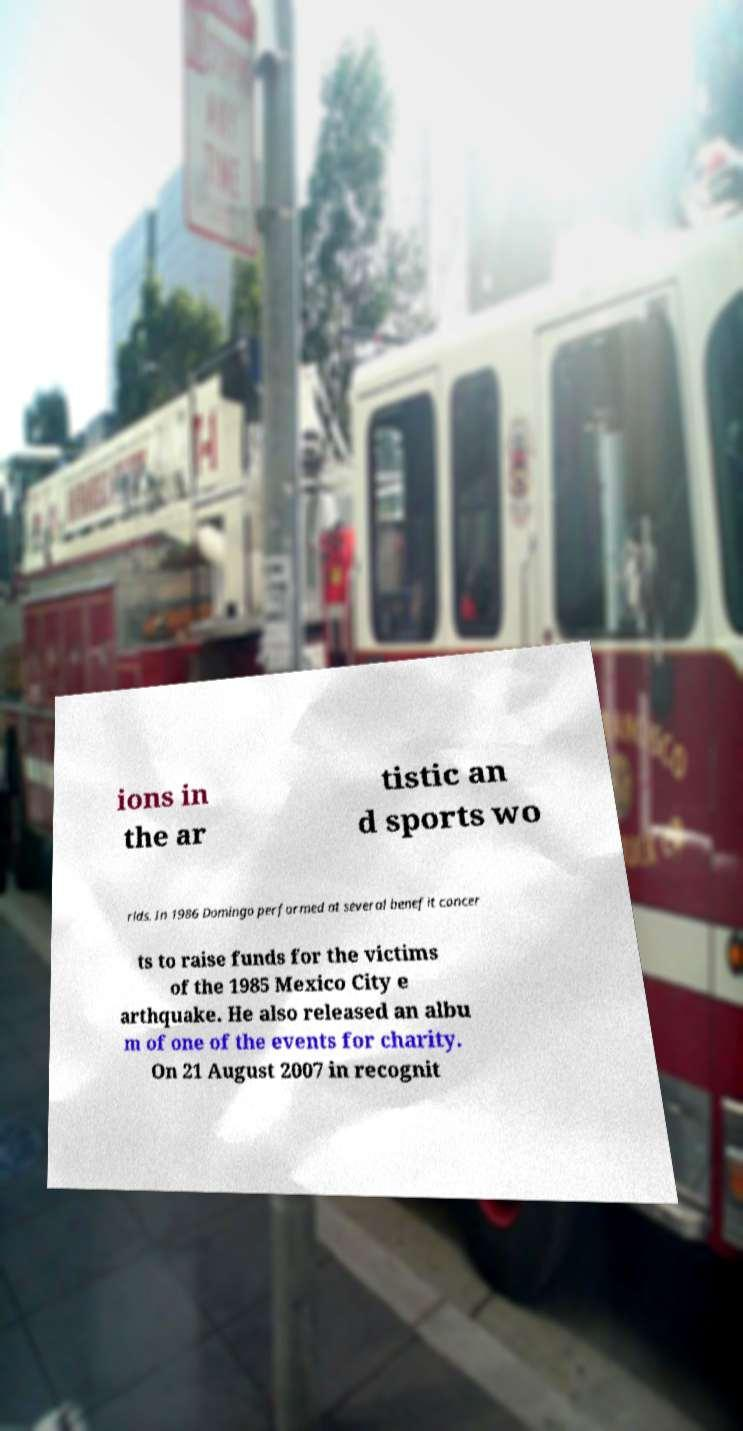For documentation purposes, I need the text within this image transcribed. Could you provide that? ions in the ar tistic an d sports wo rlds. In 1986 Domingo performed at several benefit concer ts to raise funds for the victims of the 1985 Mexico City e arthquake. He also released an albu m of one of the events for charity. On 21 August 2007 in recognit 